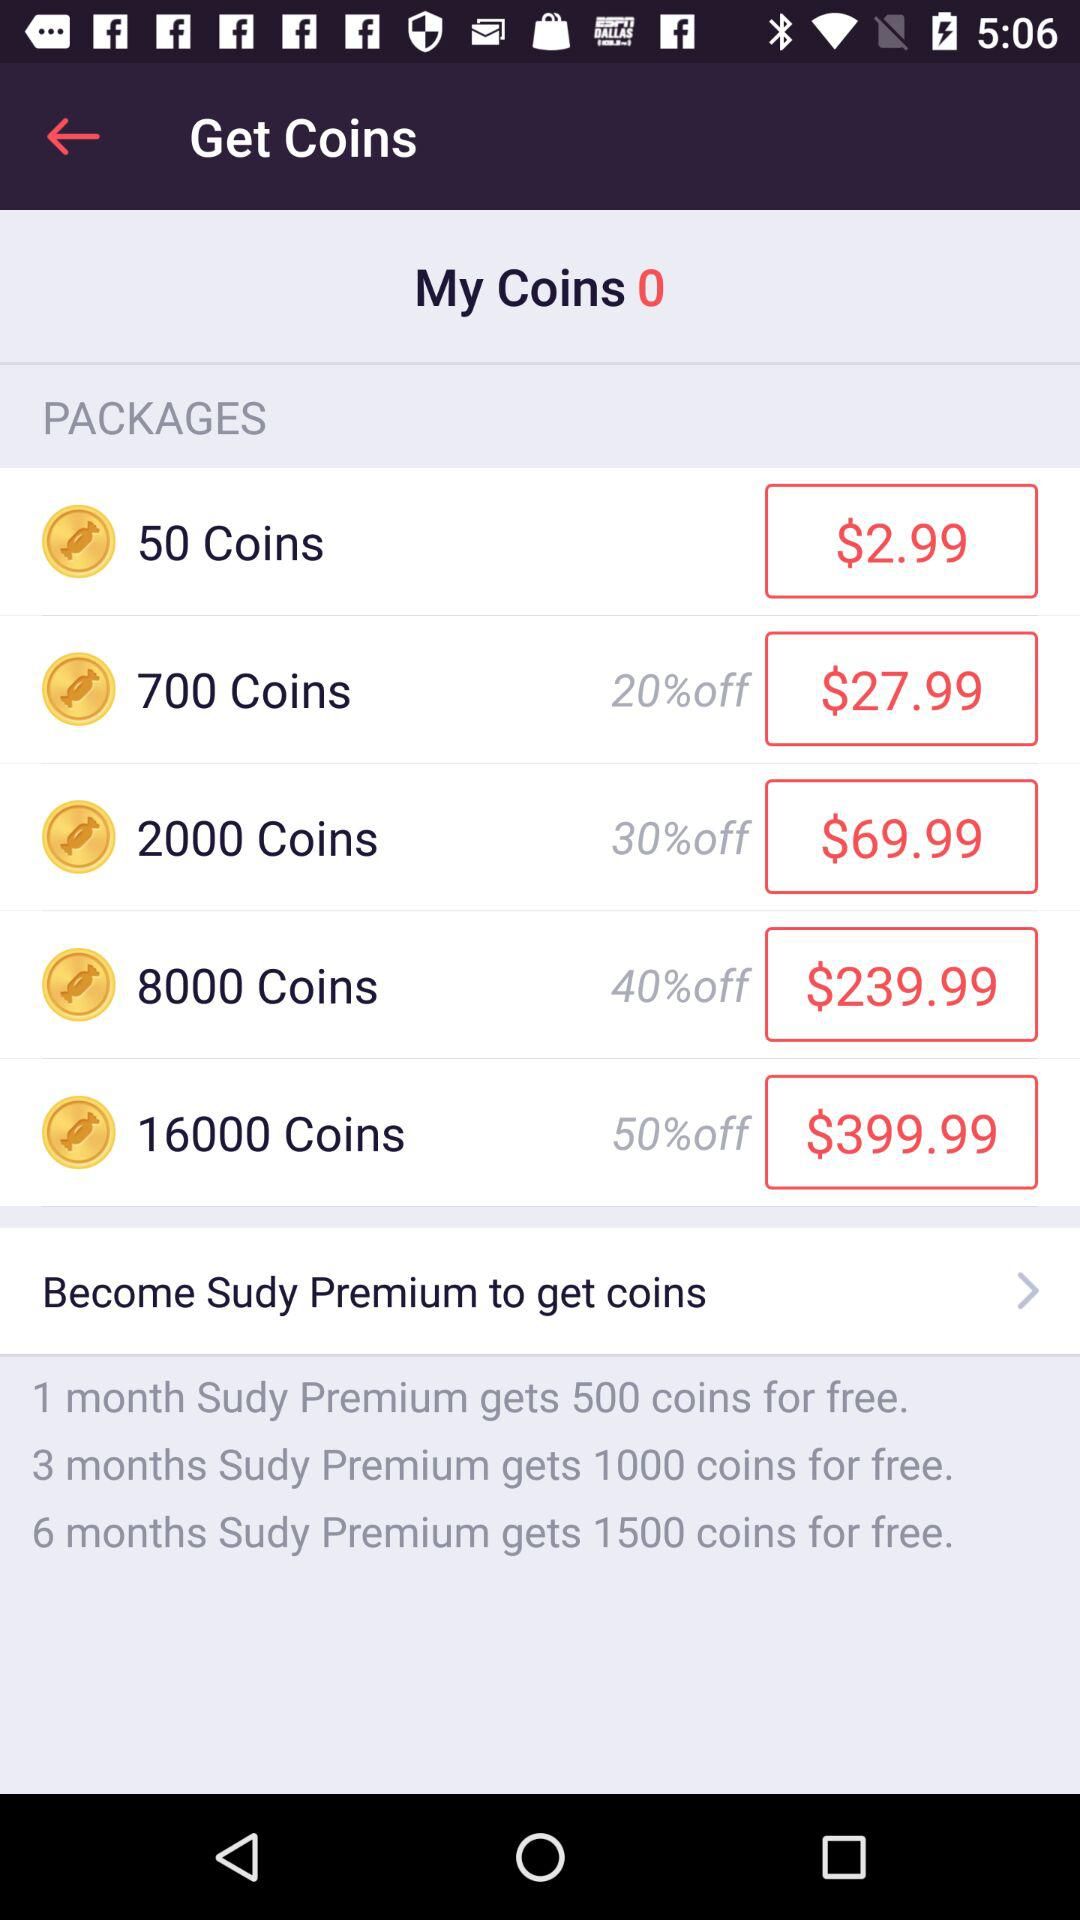How much discount is available on the purchase of 8000 coins? The available discount is 40%. 